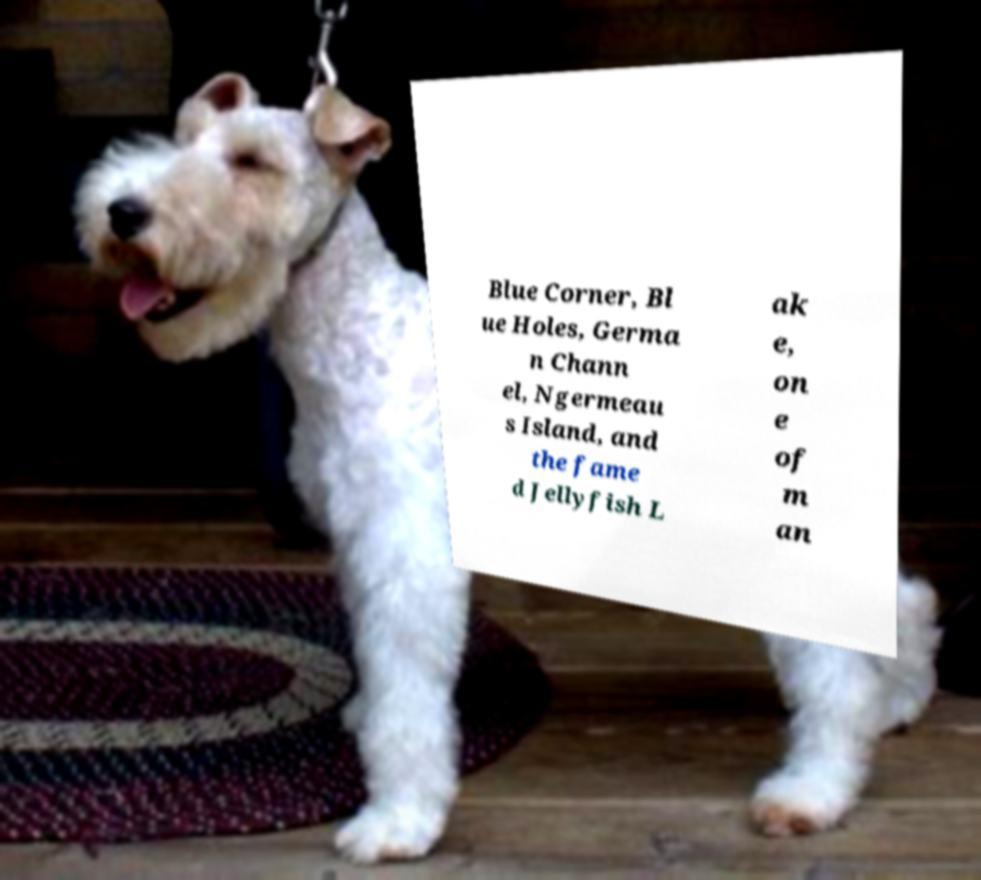For documentation purposes, I need the text within this image transcribed. Could you provide that? Blue Corner, Bl ue Holes, Germa n Chann el, Ngermeau s Island, and the fame d Jellyfish L ak e, on e of m an 